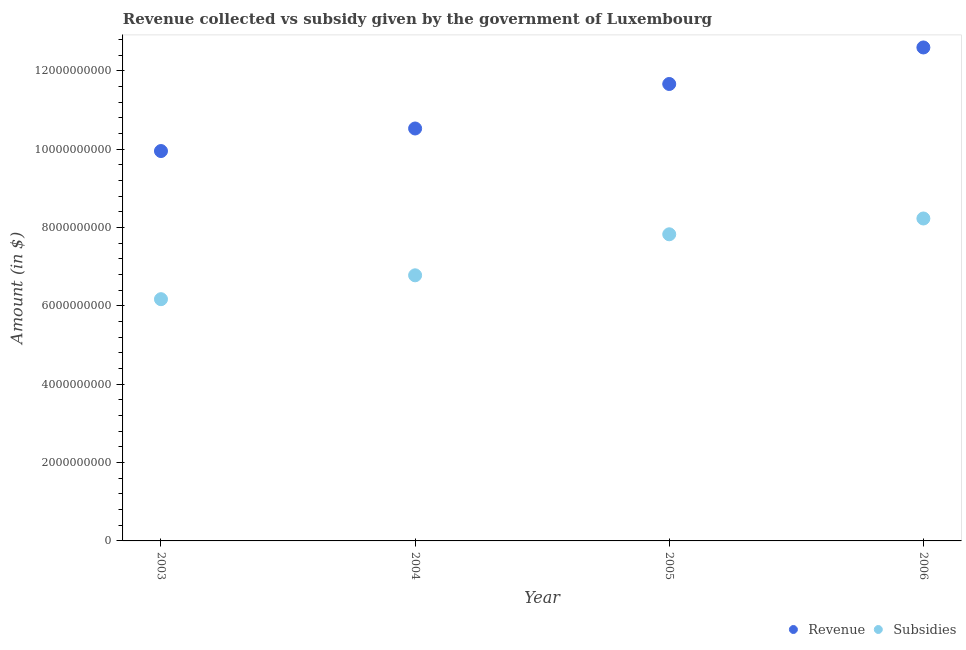What is the amount of revenue collected in 2005?
Your answer should be very brief. 1.17e+1. Across all years, what is the maximum amount of subsidies given?
Your answer should be very brief. 8.23e+09. Across all years, what is the minimum amount of revenue collected?
Ensure brevity in your answer.  9.95e+09. In which year was the amount of revenue collected maximum?
Keep it short and to the point. 2006. What is the total amount of subsidies given in the graph?
Your answer should be very brief. 2.90e+1. What is the difference between the amount of revenue collected in 2003 and that in 2005?
Provide a short and direct response. -1.71e+09. What is the difference between the amount of revenue collected in 2006 and the amount of subsidies given in 2004?
Keep it short and to the point. 5.82e+09. What is the average amount of subsidies given per year?
Give a very brief answer. 7.25e+09. In the year 2005, what is the difference between the amount of subsidies given and amount of revenue collected?
Offer a very short reply. -3.84e+09. In how many years, is the amount of revenue collected greater than 2000000000 $?
Your response must be concise. 4. What is the ratio of the amount of revenue collected in 2005 to that in 2006?
Ensure brevity in your answer.  0.93. Is the amount of revenue collected in 2003 less than that in 2006?
Ensure brevity in your answer.  Yes. What is the difference between the highest and the second highest amount of subsidies given?
Keep it short and to the point. 4.03e+08. What is the difference between the highest and the lowest amount of subsidies given?
Keep it short and to the point. 2.06e+09. In how many years, is the amount of revenue collected greater than the average amount of revenue collected taken over all years?
Provide a succinct answer. 2. Does the amount of revenue collected monotonically increase over the years?
Your answer should be very brief. Yes. Is the amount of subsidies given strictly less than the amount of revenue collected over the years?
Ensure brevity in your answer.  Yes. How many dotlines are there?
Give a very brief answer. 2. What is the difference between two consecutive major ticks on the Y-axis?
Provide a short and direct response. 2.00e+09. Are the values on the major ticks of Y-axis written in scientific E-notation?
Your answer should be very brief. No. Does the graph contain any zero values?
Your answer should be compact. No. How many legend labels are there?
Make the answer very short. 2. How are the legend labels stacked?
Give a very brief answer. Horizontal. What is the title of the graph?
Provide a short and direct response. Revenue collected vs subsidy given by the government of Luxembourg. Does "Male entrants" appear as one of the legend labels in the graph?
Provide a succinct answer. No. What is the label or title of the X-axis?
Your answer should be compact. Year. What is the label or title of the Y-axis?
Keep it short and to the point. Amount (in $). What is the Amount (in $) in Revenue in 2003?
Provide a succinct answer. 9.95e+09. What is the Amount (in $) of Subsidies in 2003?
Offer a terse response. 6.17e+09. What is the Amount (in $) in Revenue in 2004?
Your answer should be compact. 1.05e+1. What is the Amount (in $) in Subsidies in 2004?
Make the answer very short. 6.78e+09. What is the Amount (in $) of Revenue in 2005?
Provide a short and direct response. 1.17e+1. What is the Amount (in $) in Subsidies in 2005?
Keep it short and to the point. 7.83e+09. What is the Amount (in $) in Revenue in 2006?
Offer a terse response. 1.26e+1. What is the Amount (in $) in Subsidies in 2006?
Give a very brief answer. 8.23e+09. Across all years, what is the maximum Amount (in $) of Revenue?
Keep it short and to the point. 1.26e+1. Across all years, what is the maximum Amount (in $) of Subsidies?
Offer a very short reply. 8.23e+09. Across all years, what is the minimum Amount (in $) in Revenue?
Make the answer very short. 9.95e+09. Across all years, what is the minimum Amount (in $) of Subsidies?
Keep it short and to the point. 6.17e+09. What is the total Amount (in $) in Revenue in the graph?
Make the answer very short. 4.47e+1. What is the total Amount (in $) of Subsidies in the graph?
Your answer should be compact. 2.90e+1. What is the difference between the Amount (in $) in Revenue in 2003 and that in 2004?
Offer a terse response. -5.76e+08. What is the difference between the Amount (in $) in Subsidies in 2003 and that in 2004?
Provide a succinct answer. -6.09e+08. What is the difference between the Amount (in $) of Revenue in 2003 and that in 2005?
Give a very brief answer. -1.71e+09. What is the difference between the Amount (in $) of Subsidies in 2003 and that in 2005?
Your answer should be compact. -1.66e+09. What is the difference between the Amount (in $) of Revenue in 2003 and that in 2006?
Make the answer very short. -2.64e+09. What is the difference between the Amount (in $) in Subsidies in 2003 and that in 2006?
Your response must be concise. -2.06e+09. What is the difference between the Amount (in $) of Revenue in 2004 and that in 2005?
Give a very brief answer. -1.14e+09. What is the difference between the Amount (in $) in Subsidies in 2004 and that in 2005?
Offer a very short reply. -1.05e+09. What is the difference between the Amount (in $) in Revenue in 2004 and that in 2006?
Your answer should be compact. -2.07e+09. What is the difference between the Amount (in $) of Subsidies in 2004 and that in 2006?
Offer a terse response. -1.45e+09. What is the difference between the Amount (in $) in Revenue in 2005 and that in 2006?
Provide a succinct answer. -9.32e+08. What is the difference between the Amount (in $) in Subsidies in 2005 and that in 2006?
Offer a terse response. -4.03e+08. What is the difference between the Amount (in $) of Revenue in 2003 and the Amount (in $) of Subsidies in 2004?
Ensure brevity in your answer.  3.17e+09. What is the difference between the Amount (in $) of Revenue in 2003 and the Amount (in $) of Subsidies in 2005?
Offer a terse response. 2.13e+09. What is the difference between the Amount (in $) of Revenue in 2003 and the Amount (in $) of Subsidies in 2006?
Make the answer very short. 1.72e+09. What is the difference between the Amount (in $) in Revenue in 2004 and the Amount (in $) in Subsidies in 2005?
Your answer should be very brief. 2.70e+09. What is the difference between the Amount (in $) of Revenue in 2004 and the Amount (in $) of Subsidies in 2006?
Offer a terse response. 2.30e+09. What is the difference between the Amount (in $) in Revenue in 2005 and the Amount (in $) in Subsidies in 2006?
Keep it short and to the point. 3.43e+09. What is the average Amount (in $) in Revenue per year?
Your response must be concise. 1.12e+1. What is the average Amount (in $) in Subsidies per year?
Offer a terse response. 7.25e+09. In the year 2003, what is the difference between the Amount (in $) of Revenue and Amount (in $) of Subsidies?
Offer a terse response. 3.78e+09. In the year 2004, what is the difference between the Amount (in $) of Revenue and Amount (in $) of Subsidies?
Offer a very short reply. 3.75e+09. In the year 2005, what is the difference between the Amount (in $) of Revenue and Amount (in $) of Subsidies?
Offer a very short reply. 3.84e+09. In the year 2006, what is the difference between the Amount (in $) of Revenue and Amount (in $) of Subsidies?
Offer a very short reply. 4.37e+09. What is the ratio of the Amount (in $) of Revenue in 2003 to that in 2004?
Offer a very short reply. 0.95. What is the ratio of the Amount (in $) of Subsidies in 2003 to that in 2004?
Offer a very short reply. 0.91. What is the ratio of the Amount (in $) in Revenue in 2003 to that in 2005?
Make the answer very short. 0.85. What is the ratio of the Amount (in $) in Subsidies in 2003 to that in 2005?
Your answer should be very brief. 0.79. What is the ratio of the Amount (in $) of Revenue in 2003 to that in 2006?
Offer a terse response. 0.79. What is the ratio of the Amount (in $) in Subsidies in 2003 to that in 2006?
Give a very brief answer. 0.75. What is the ratio of the Amount (in $) of Revenue in 2004 to that in 2005?
Your answer should be very brief. 0.9. What is the ratio of the Amount (in $) of Subsidies in 2004 to that in 2005?
Give a very brief answer. 0.87. What is the ratio of the Amount (in $) of Revenue in 2004 to that in 2006?
Offer a terse response. 0.84. What is the ratio of the Amount (in $) of Subsidies in 2004 to that in 2006?
Give a very brief answer. 0.82. What is the ratio of the Amount (in $) in Revenue in 2005 to that in 2006?
Provide a succinct answer. 0.93. What is the ratio of the Amount (in $) in Subsidies in 2005 to that in 2006?
Offer a very short reply. 0.95. What is the difference between the highest and the second highest Amount (in $) in Revenue?
Ensure brevity in your answer.  9.32e+08. What is the difference between the highest and the second highest Amount (in $) of Subsidies?
Offer a very short reply. 4.03e+08. What is the difference between the highest and the lowest Amount (in $) in Revenue?
Offer a terse response. 2.64e+09. What is the difference between the highest and the lowest Amount (in $) in Subsidies?
Provide a short and direct response. 2.06e+09. 